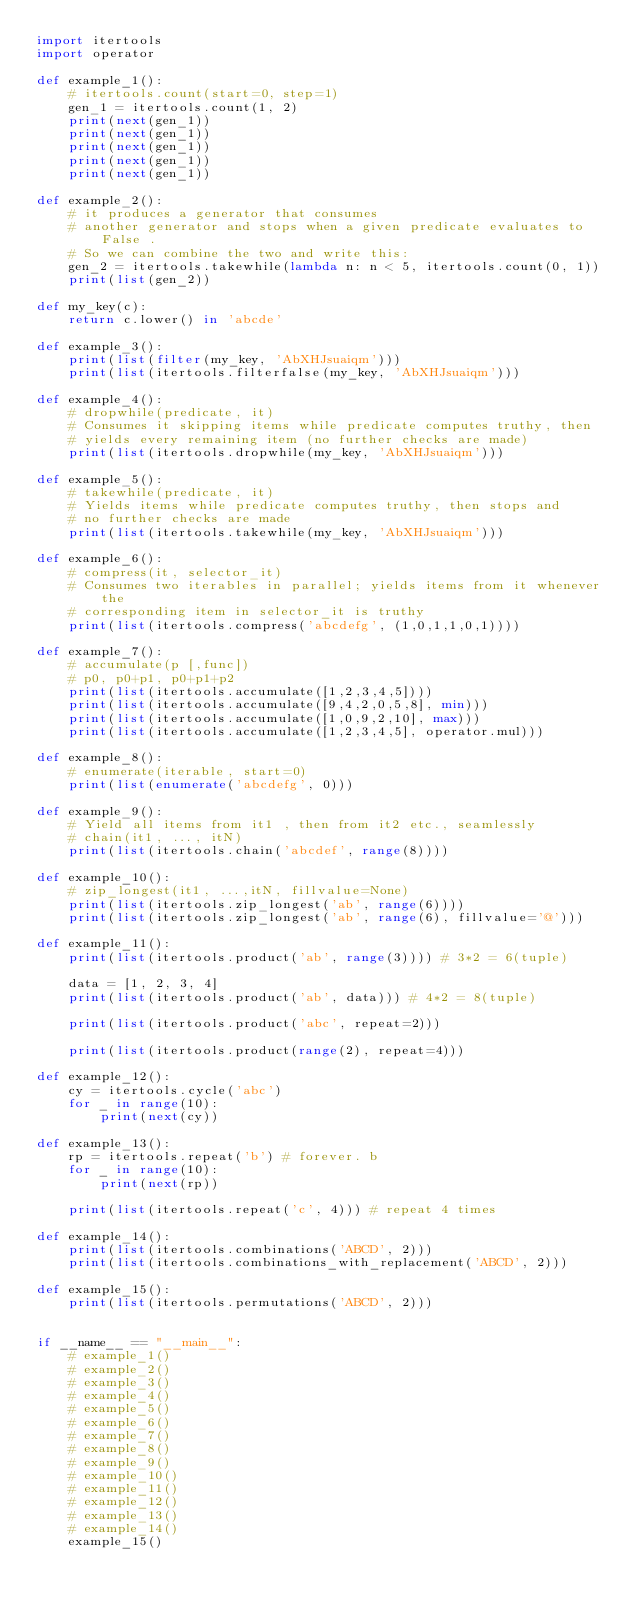Convert code to text. <code><loc_0><loc_0><loc_500><loc_500><_Python_>import itertools
import operator

def example_1():
    # itertools.count(start=0, step=1)
    gen_1 = itertools.count(1, 2)
    print(next(gen_1))
    print(next(gen_1))
    print(next(gen_1))
    print(next(gen_1))
    print(next(gen_1))

def example_2():
    # it produces a generator that consumes
    # another generator and stops when a given predicate evaluates to False .
    # So we can combine the two and write this:
    gen_2 = itertools.takewhile(lambda n: n < 5, itertools.count(0, 1))
    print(list(gen_2))

def my_key(c):
    return c.lower() in 'abcde'

def example_3():
    print(list(filter(my_key, 'AbXHJsuaiqm')))
    print(list(itertools.filterfalse(my_key, 'AbXHJsuaiqm')))

def example_4():
    # dropwhile(predicate, it)
    # Consumes it skipping items while predicate computes truthy, then
    # yields every remaining item (no further checks are made)
    print(list(itertools.dropwhile(my_key, 'AbXHJsuaiqm')))

def example_5():
    # takewhile(predicate, it)
    # Yields items while predicate computes truthy, then stops and
    # no further checks are made
    print(list(itertools.takewhile(my_key, 'AbXHJsuaiqm')))

def example_6():
    # compress(it, selector_it)
    # Consumes two iterables in parallel; yields items from it whenever the
    # corresponding item in selector_it is truthy
    print(list(itertools.compress('abcdefg', (1,0,1,1,0,1))))

def example_7():
    # accumulate(p [,func])
    # p0, p0+p1, p0+p1+p2
    print(list(itertools.accumulate([1,2,3,4,5])))
    print(list(itertools.accumulate([9,4,2,0,5,8], min)))
    print(list(itertools.accumulate([1,0,9,2,10], max)))
    print(list(itertools.accumulate([1,2,3,4,5], operator.mul)))

def example_8():
    # enumerate(iterable, start=0)
    print(list(enumerate('abcdefg', 0)))

def example_9():
    # Yield all items from it1 , then from it2 etc., seamlessly
    # chain(it1, ..., itN)
    print(list(itertools.chain('abcdef', range(8))))

def example_10():
    # zip_longest(it1, ...,itN, fillvalue=None)
    print(list(itertools.zip_longest('ab', range(6))))
    print(list(itertools.zip_longest('ab', range(6), fillvalue='@')))

def example_11():
    print(list(itertools.product('ab', range(3)))) # 3*2 = 6(tuple)

    data = [1, 2, 3, 4]
    print(list(itertools.product('ab', data))) # 4*2 = 8(tuple)

    print(list(itertools.product('abc', repeat=2)))

    print(list(itertools.product(range(2), repeat=4)))

def example_12():
    cy = itertools.cycle('abc')
    for _ in range(10):
        print(next(cy))

def example_13():
    rp = itertools.repeat('b') # forever. b
    for _ in range(10):
        print(next(rp))

    print(list(itertools.repeat('c', 4))) # repeat 4 times

def example_14():
    print(list(itertools.combinations('ABCD', 2)))
    print(list(itertools.combinations_with_replacement('ABCD', 2)))

def example_15():
    print(list(itertools.permutations('ABCD', 2)))


if __name__ == "__main__":
    # example_1()
    # example_2()
    # example_3()
    # example_4()
    # example_5()
    # example_6()
    # example_7()
    # example_8()
    # example_9()
    # example_10()
    # example_11()
    # example_12()
    # example_13()
    # example_14()
    example_15()
</code> 